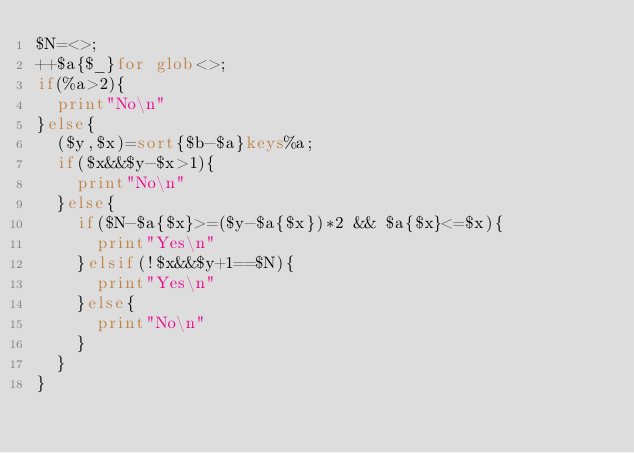<code> <loc_0><loc_0><loc_500><loc_500><_Perl_>$N=<>;
++$a{$_}for glob<>;
if(%a>2){
	print"No\n"
}else{
	($y,$x)=sort{$b-$a}keys%a;
	if($x&&$y-$x>1){
		print"No\n"
	}else{
		if($N-$a{$x}>=($y-$a{$x})*2 && $a{$x}<=$x){
			print"Yes\n"
		}elsif(!$x&&$y+1==$N){
			print"Yes\n"
		}else{
			print"No\n"
		}
	}
}
</code> 